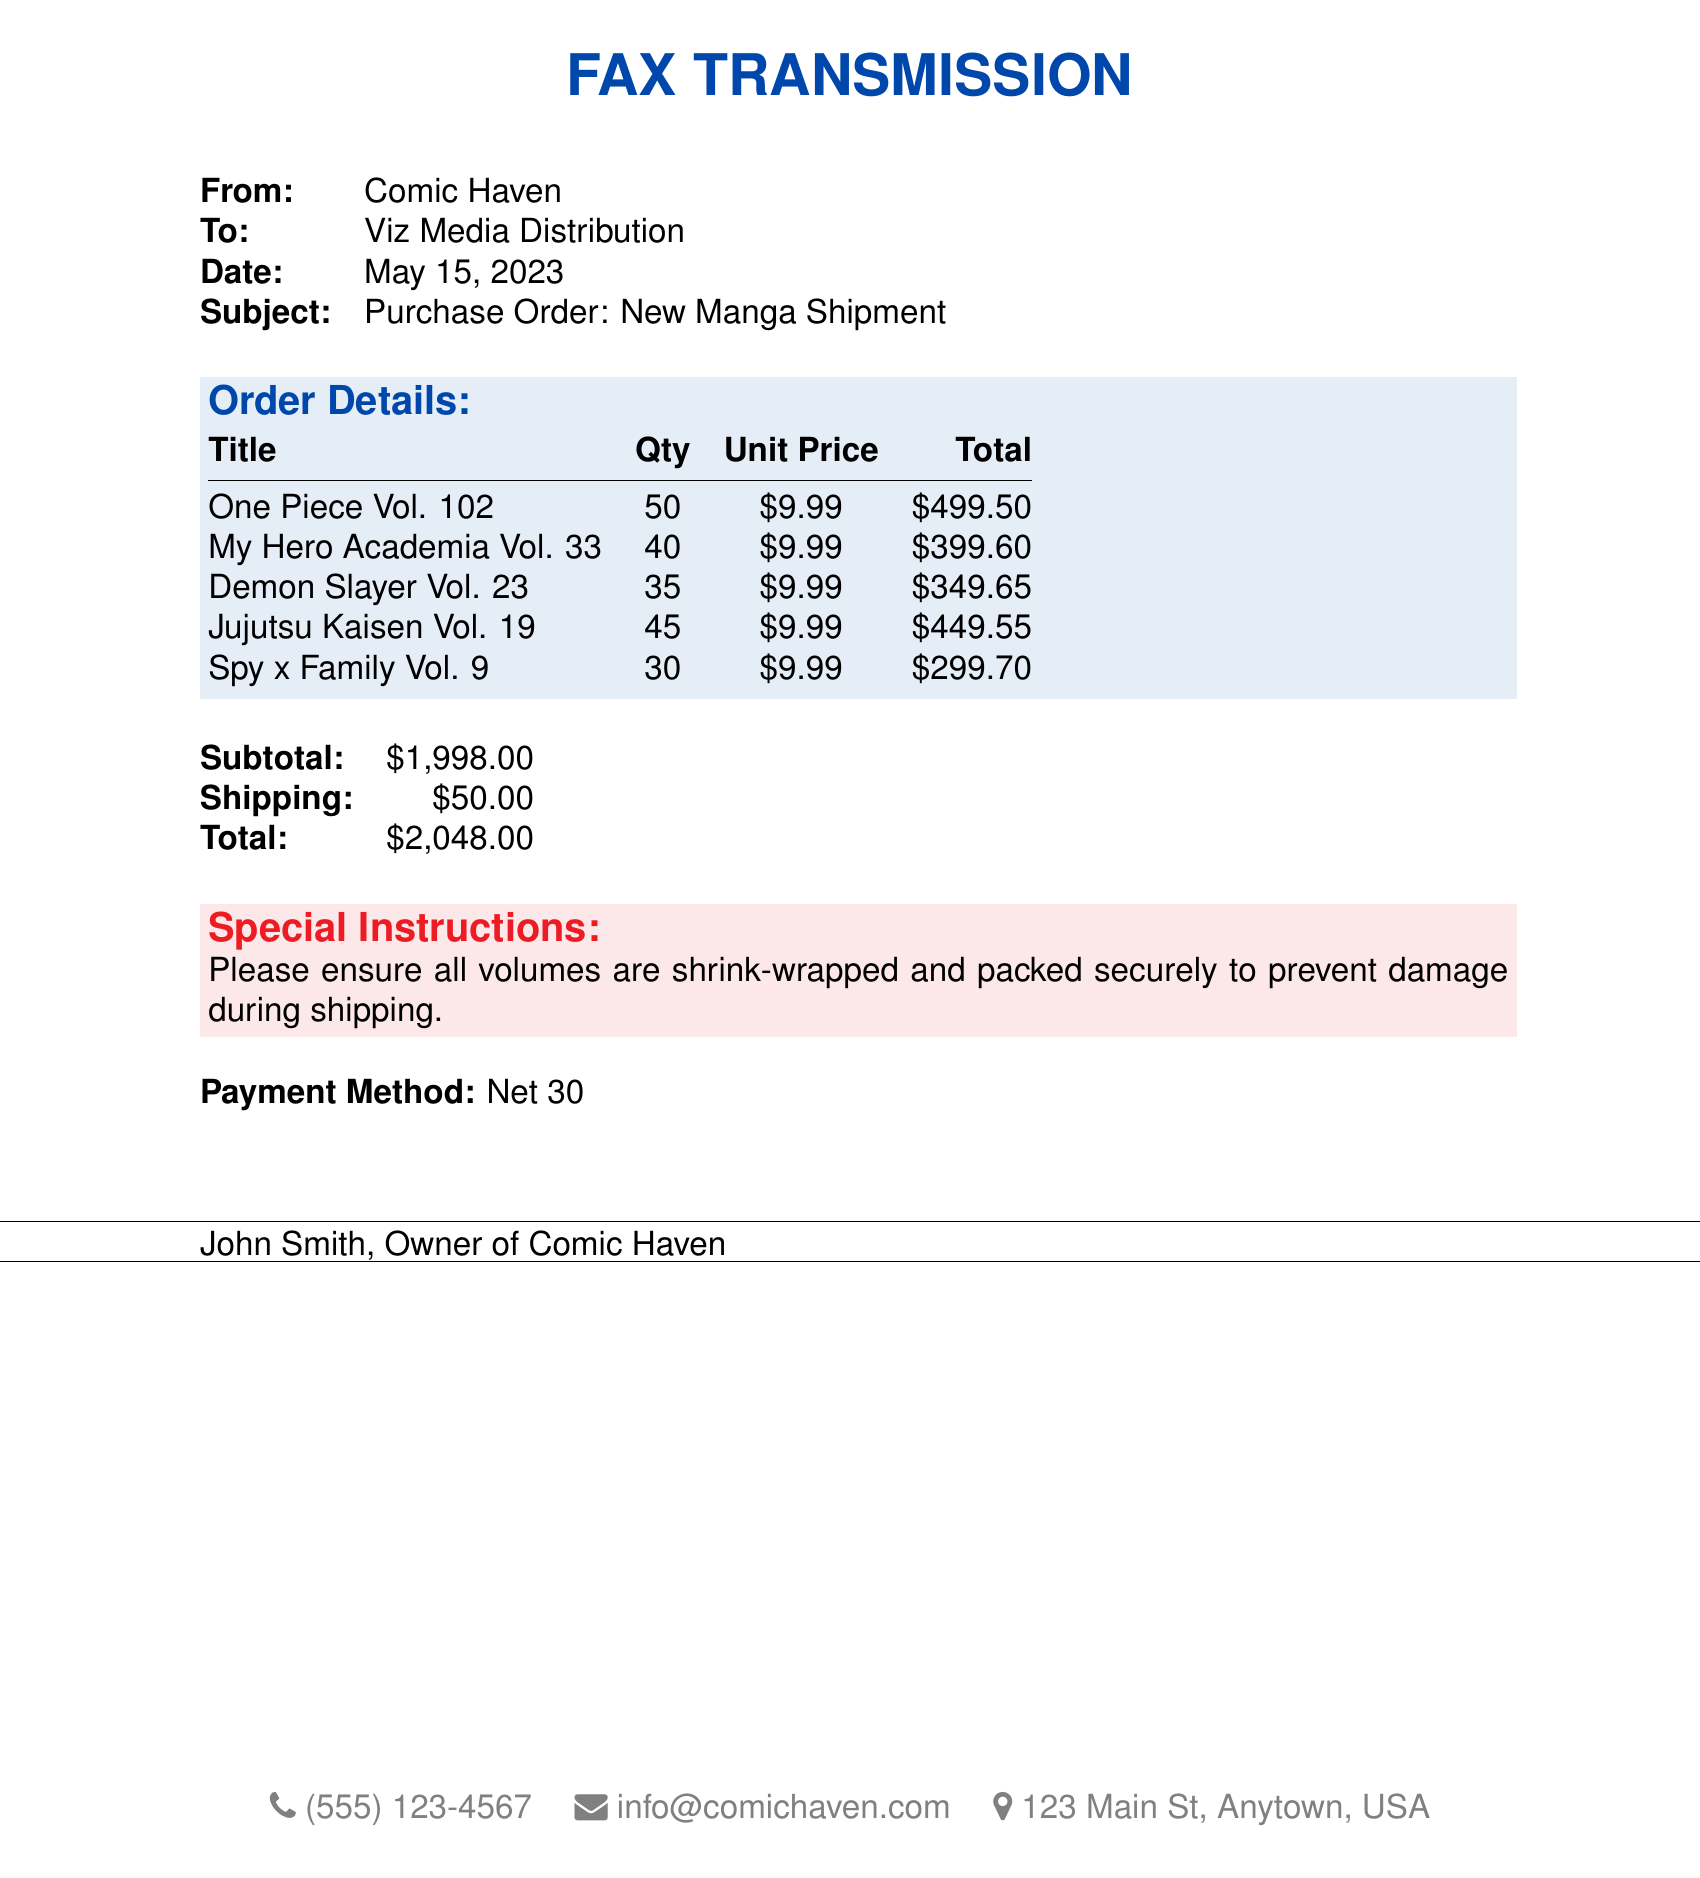What is the date of the fax? The date listed in the fax is May 15, 2023.
Answer: May 15, 2023 Who is the recipient of the fax? The fax is addressed to Viz Media Distribution.
Answer: Viz Media Distribution What is the unit price of "Spy x Family Vol. 9"? The unit price for "Spy x Family Vol. 9" is listed in the order details as $9.99.
Answer: $9.99 How many copies of "My Hero Academia Vol. 33" were ordered? The quantity ordered for "My Hero Academia Vol. 33" is stated in the order as 40.
Answer: 40 What is the subtotal amount of the order? The subtotal is calculated from the total quantities and prices of all items in the order, which is $1,998.00.
Answer: $1,998.00 What special instructions were given regarding the shipment? The special instructions mention that all volumes should be shrink-wrapped and packed securely to prevent damage.
Answer: Shrink-wrapped and packed securely What is the total cost including shipping? The total cost is displayed at the end of the document, which combines subtotal and shipping charges, totaling $2,048.00.
Answer: $2,048.00 What payment method is specified in the fax? The fax indicates that the payment method is Net 30.
Answer: Net 30 How many titles are included in the order? The order lists five different manga titles in the details.
Answer: Five 